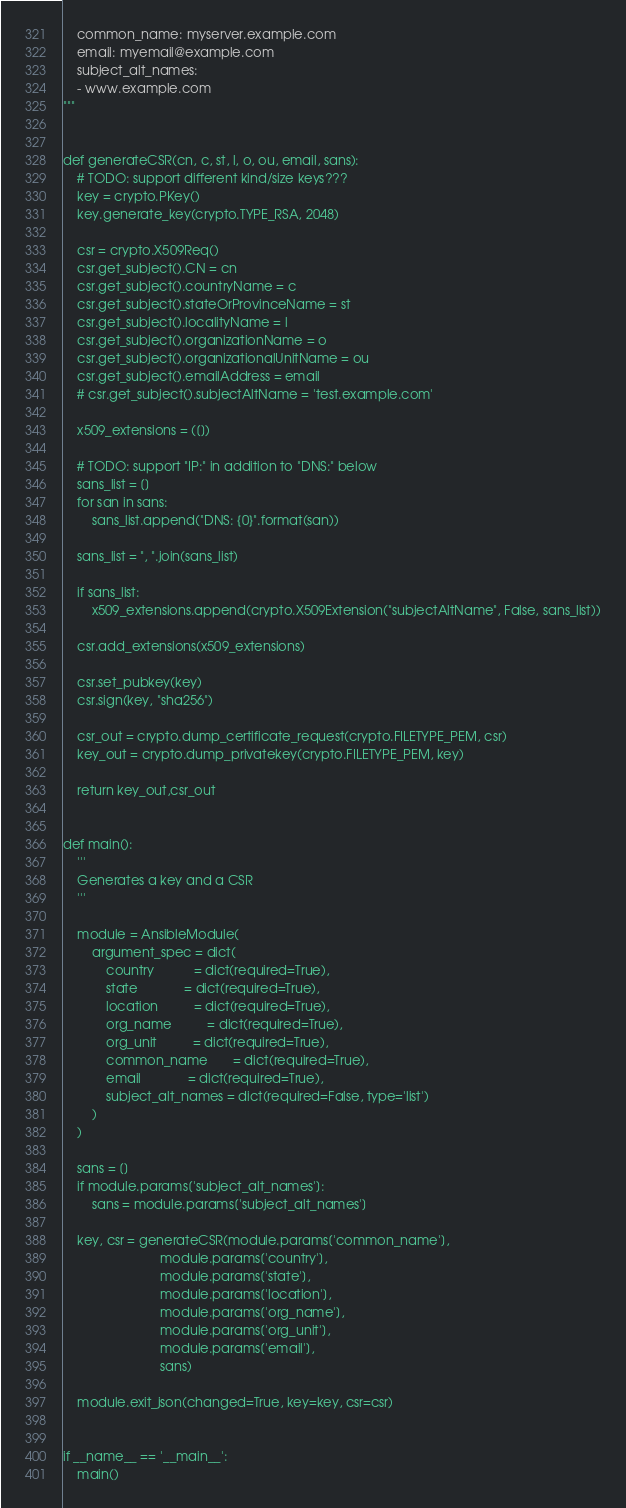Convert code to text. <code><loc_0><loc_0><loc_500><loc_500><_Python_>    common_name: myserver.example.com
    email: myemail@example.com
    subject_alt_names:
    - www.example.com
"""


def generateCSR(cn, c, st, l, o, ou, email, sans):
    # TODO: support different kind/size keys???
    key = crypto.PKey()
    key.generate_key(crypto.TYPE_RSA, 2048)

    csr = crypto.X509Req()
    csr.get_subject().CN = cn
    csr.get_subject().countryName = c
    csr.get_subject().stateOrProvinceName = st
    csr.get_subject().localityName = l
    csr.get_subject().organizationName = o
    csr.get_subject().organizationalUnitName = ou
    csr.get_subject().emailAddress = email
    # csr.get_subject().subjectAltName = 'test.example.com'

    x509_extensions = ([])

    # TODO: support "IP:" in addition to "DNS:" below
    sans_list = []
    for san in sans:
        sans_list.append("DNS: {0}".format(san))

    sans_list = ", ".join(sans_list)

    if sans_list:
        x509_extensions.append(crypto.X509Extension("subjectAltName", False, sans_list))

    csr.add_extensions(x509_extensions)

    csr.set_pubkey(key)
    csr.sign(key, "sha256")

    csr_out = crypto.dump_certificate_request(crypto.FILETYPE_PEM, csr)
    key_out = crypto.dump_privatekey(crypto.FILETYPE_PEM, key)

    return key_out,csr_out


def main():
    '''
    Generates a key and a CSR
    '''

    module = AnsibleModule(
        argument_spec = dict(
            country           = dict(required=True),
            state             = dict(required=True),
            location          = dict(required=True),
            org_name          = dict(required=True),
            org_unit          = dict(required=True),
            common_name       = dict(required=True),
            email             = dict(required=True),
            subject_alt_names = dict(required=False, type='list')
        )
    )

    sans = []
    if module.params['subject_alt_names']:
        sans = module.params['subject_alt_names']

    key, csr = generateCSR(module.params['common_name'],
                           module.params['country'],
                           module.params['state'],
                           module.params['location'],
                           module.params['org_name'],
                           module.params['org_unit'],
                           module.params['email'],
                           sans)

    module.exit_json(changed=True, key=key, csr=csr)


if __name__ == '__main__':
    main()
</code> 